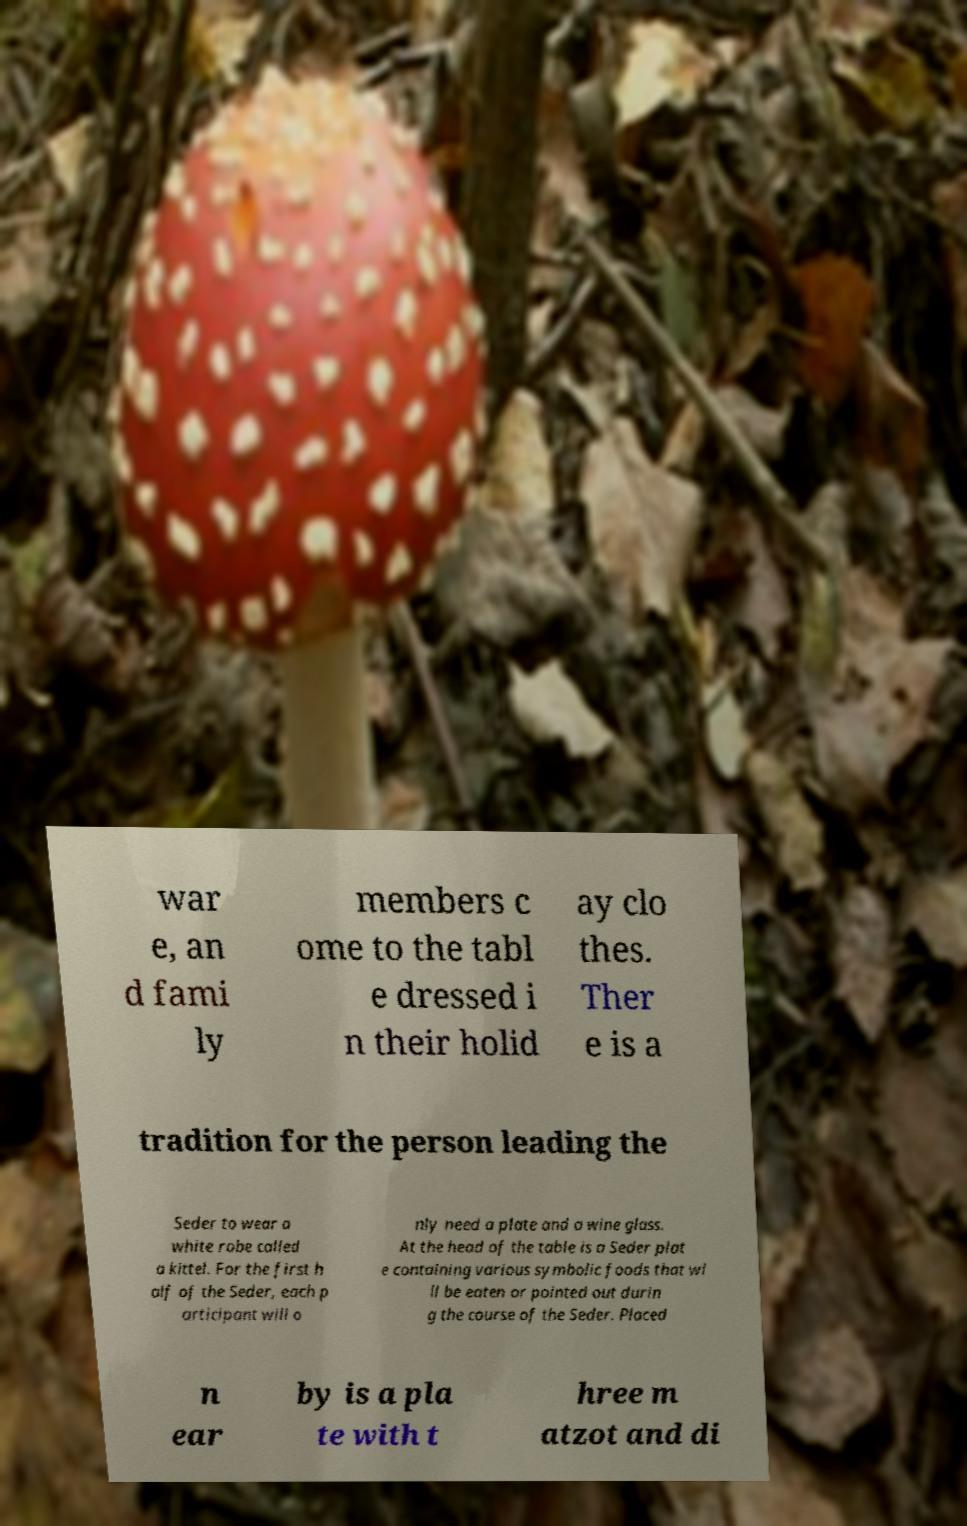Please read and relay the text visible in this image. What does it say? war e, an d fami ly members c ome to the tabl e dressed i n their holid ay clo thes. Ther e is a tradition for the person leading the Seder to wear a white robe called a kittel. For the first h alf of the Seder, each p articipant will o nly need a plate and a wine glass. At the head of the table is a Seder plat e containing various symbolic foods that wi ll be eaten or pointed out durin g the course of the Seder. Placed n ear by is a pla te with t hree m atzot and di 